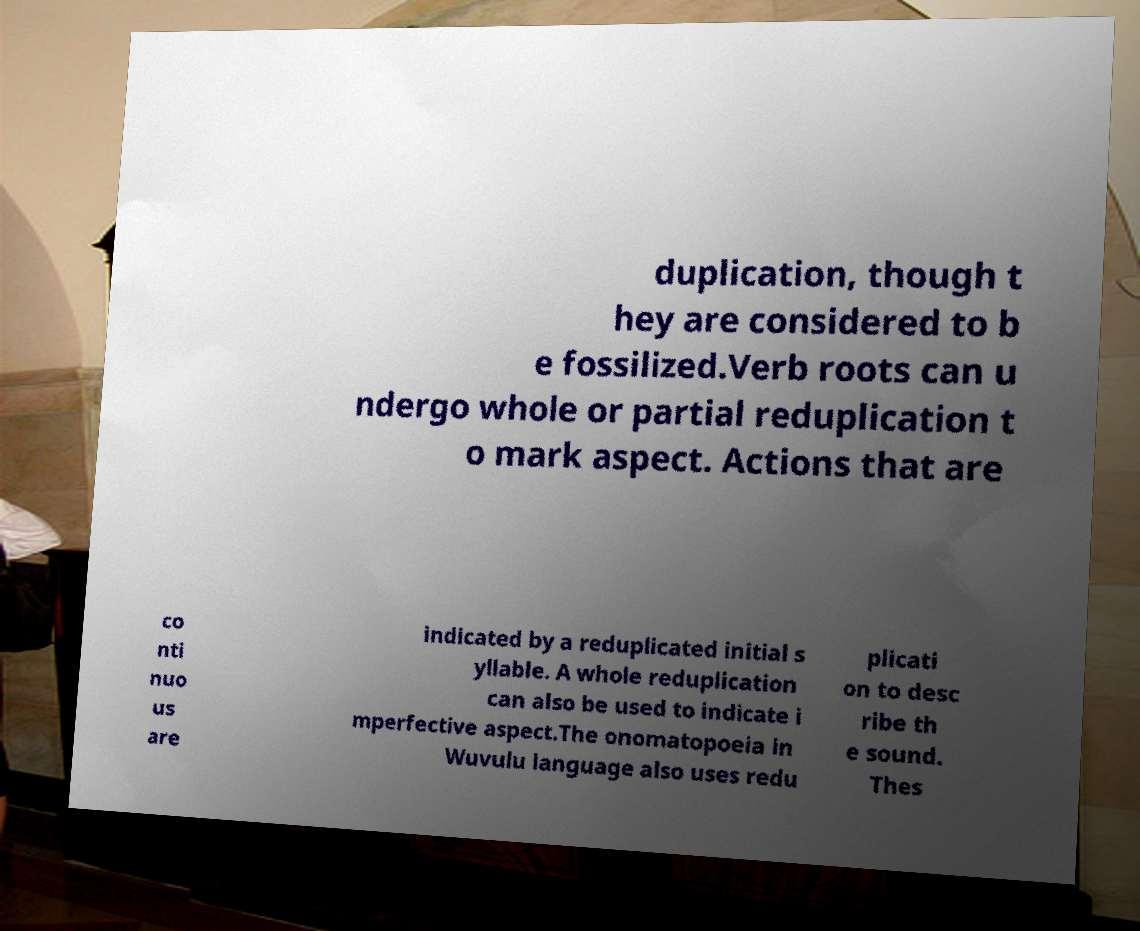Can you accurately transcribe the text from the provided image for me? duplication, though t hey are considered to b e fossilized.Verb roots can u ndergo whole or partial reduplication t o mark aspect. Actions that are co nti nuo us are indicated by a reduplicated initial s yllable. A whole reduplication can also be used to indicate i mperfective aspect.The onomatopoeia in Wuvulu language also uses redu plicati on to desc ribe th e sound. Thes 